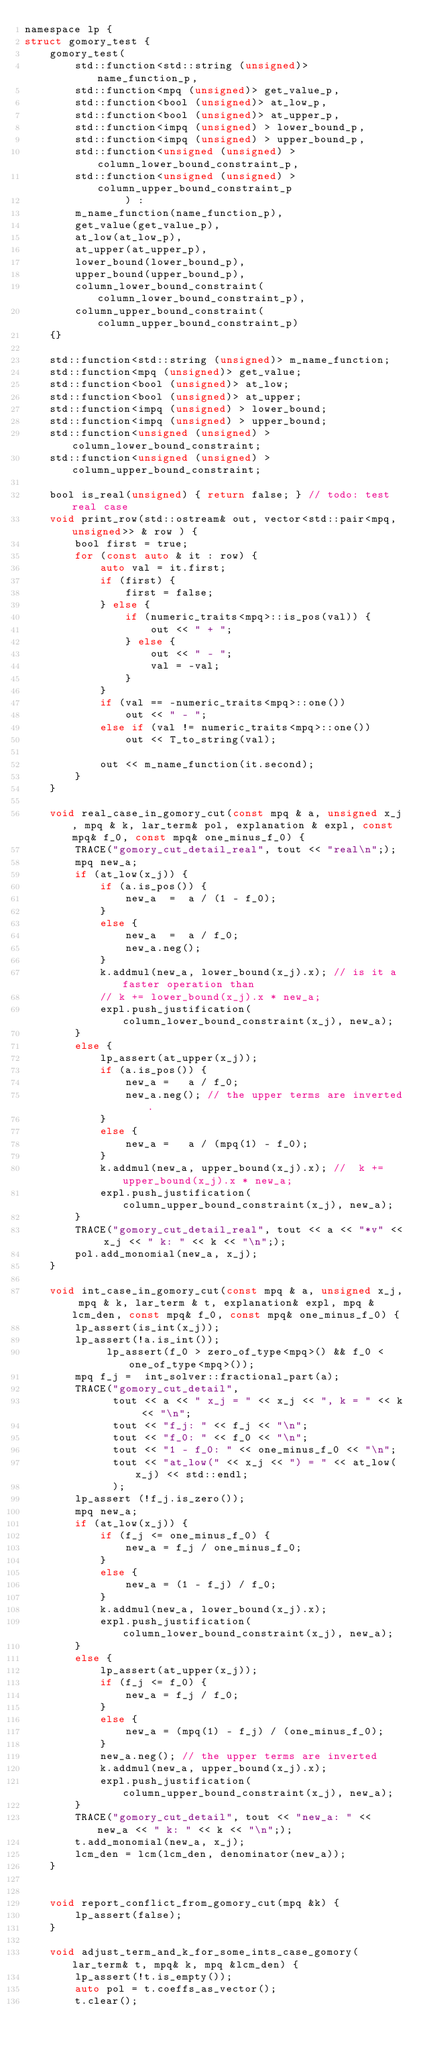<code> <loc_0><loc_0><loc_500><loc_500><_C_>namespace lp {
struct gomory_test {
    gomory_test(
        std::function<std::string (unsigned)> name_function_p,
        std::function<mpq (unsigned)> get_value_p,
        std::function<bool (unsigned)> at_low_p,
        std::function<bool (unsigned)> at_upper_p,
        std::function<impq (unsigned) > lower_bound_p,
        std::function<impq (unsigned) > upper_bound_p,
        std::function<unsigned (unsigned) > column_lower_bound_constraint_p,
        std::function<unsigned (unsigned) > column_upper_bound_constraint_p
                ) :
        m_name_function(name_function_p),
        get_value(get_value_p),
        at_low(at_low_p),
        at_upper(at_upper_p),
        lower_bound(lower_bound_p),
        upper_bound(upper_bound_p),
        column_lower_bound_constraint(column_lower_bound_constraint_p),
        column_upper_bound_constraint(column_upper_bound_constraint_p)
    {}

    std::function<std::string (unsigned)> m_name_function;
    std::function<mpq (unsigned)> get_value;
    std::function<bool (unsigned)> at_low;
    std::function<bool (unsigned)> at_upper;
    std::function<impq (unsigned) > lower_bound;
    std::function<impq (unsigned) > upper_bound;
    std::function<unsigned (unsigned) > column_lower_bound_constraint;
    std::function<unsigned (unsigned) > column_upper_bound_constraint;
    
    bool is_real(unsigned) { return false; } // todo: test real case
    void print_row(std::ostream& out, vector<std::pair<mpq, unsigned>> & row ) {
        bool first = true;
        for (const auto & it : row) {
            auto val = it.first;
            if (first) {
                first = false;
            } else {
                if (numeric_traits<mpq>::is_pos(val)) {
                    out << " + ";
                } else {
                    out << " - ";
                    val = -val;
                }
            }
            if (val == -numeric_traits<mpq>::one())
                out << " - ";
            else if (val != numeric_traits<mpq>::one())
                out << T_to_string(val);
        
            out << m_name_function(it.second);
        }
    }

    void real_case_in_gomory_cut(const mpq & a, unsigned x_j, mpq & k, lar_term& pol, explanation & expl, const mpq& f_0, const mpq& one_minus_f_0) {
        TRACE("gomory_cut_detail_real", tout << "real\n";);
        mpq new_a;
        if (at_low(x_j)) {
            if (a.is_pos()) {
                new_a  =  a / (1 - f_0);
            }
            else {
                new_a  =  a / f_0;
                new_a.neg();
            }
            k.addmul(new_a, lower_bound(x_j).x); // is it a faster operation than
            // k += lower_bound(x_j).x * new_a;  
            expl.push_justification(column_lower_bound_constraint(x_j), new_a);
        }
        else {
            lp_assert(at_upper(x_j));
            if (a.is_pos()) {
                new_a =   a / f_0; 
                new_a.neg(); // the upper terms are inverted.
            }
            else {
                new_a =   a / (mpq(1) - f_0); 
            }
            k.addmul(new_a, upper_bound(x_j).x); //  k += upper_bound(x_j).x * new_a; 
            expl.push_justification(column_upper_bound_constraint(x_j), new_a);
        }
        TRACE("gomory_cut_detail_real", tout << a << "*v" << x_j << " k: " << k << "\n";);
        pol.add_monomial(new_a, x_j);
    }
    
    void int_case_in_gomory_cut(const mpq & a, unsigned x_j, mpq & k, lar_term & t, explanation& expl, mpq & lcm_den, const mpq& f_0, const mpq& one_minus_f_0) {
        lp_assert(is_int(x_j));
        lp_assert(!a.is_int());
             lp_assert(f_0 > zero_of_type<mpq>() && f_0 < one_of_type<mpq>());
        mpq f_j =  int_solver::fractional_part(a);
        TRACE("gomory_cut_detail", 
              tout << a << " x_j = " << x_j << ", k = " << k << "\n";
              tout << "f_j: " << f_j << "\n";
              tout << "f_0: " << f_0 << "\n";
              tout << "1 - f_0: " << one_minus_f_0 << "\n";
              tout << "at_low(" << x_j << ") = " << at_low(x_j) << std::endl;
              );
        lp_assert (!f_j.is_zero());
        mpq new_a;
        if (at_low(x_j)) {
            if (f_j <= one_minus_f_0) {
                new_a = f_j / one_minus_f_0;
            }
            else {
                new_a = (1 - f_j) / f_0;
            }
            k.addmul(new_a, lower_bound(x_j).x);
            expl.push_justification(column_lower_bound_constraint(x_j), new_a);
        }
        else {
            lp_assert(at_upper(x_j));
            if (f_j <= f_0) {
                new_a = f_j / f_0;
            }
            else {
                new_a = (mpq(1) - f_j) / (one_minus_f_0);
            }
            new_a.neg(); // the upper terms are inverted
            k.addmul(new_a, upper_bound(x_j).x);
            expl.push_justification(column_upper_bound_constraint(x_j), new_a);
        }
        TRACE("gomory_cut_detail", tout << "new_a: " << new_a << " k: " << k << "\n";);
        t.add_monomial(new_a, x_j);
        lcm_den = lcm(lcm_den, denominator(new_a));
    }


    void report_conflict_from_gomory_cut(mpq &k) {
        lp_assert(false);
    }

    void adjust_term_and_k_for_some_ints_case_gomory(lar_term& t, mpq& k, mpq &lcm_den) {
        lp_assert(!t.is_empty());
        auto pol = t.coeffs_as_vector();
        t.clear();</code> 